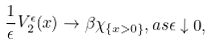Convert formula to latex. <formula><loc_0><loc_0><loc_500><loc_500>\frac { 1 } { \epsilon } V ^ { \epsilon } _ { 2 } ( x ) \rightarrow \beta \chi _ { \{ x > 0 \} } , a s \epsilon \downarrow 0 ,</formula> 